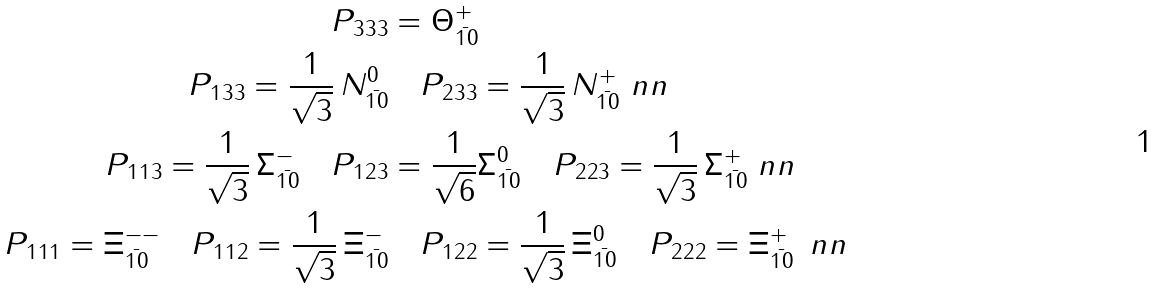<formula> <loc_0><loc_0><loc_500><loc_500>P _ { 3 3 3 } & = \Theta ^ { + } _ { \bar { 1 0 } } \\ P _ { 1 3 3 } = \frac { 1 } { \sqrt { 3 } } \, N ^ { 0 } _ { \bar { 1 0 } } & \quad P _ { 2 3 3 } = \frac { 1 } { \sqrt { 3 } } \, N ^ { + } _ { \bar { 1 0 } } \ n n \\ P _ { 1 1 3 } = \frac { 1 } { \sqrt { 3 } } \, \Sigma ^ { - } _ { \bar { 1 0 } } \quad P _ { 1 2 3 } & = \frac { 1 } { \sqrt { 6 } } \Sigma ^ { 0 } _ { \bar { 1 0 } } \quad P _ { 2 2 3 } = \frac { 1 } { \sqrt { 3 } } \, \Sigma ^ { + } _ { \bar { 1 0 } } \ n n \\ P _ { 1 1 1 } = \Xi ^ { - - } _ { \bar { 1 0 } } \quad P _ { 1 1 2 } = \frac { 1 } { \sqrt { 3 } } \, \Xi _ { \bar { 1 0 } } ^ { - } & \quad P _ { 1 2 2 } = \frac { 1 } { \sqrt { 3 } } \, \Xi _ { \bar { 1 0 } } ^ { 0 } \quad P _ { 2 2 2 } = \Xi _ { \bar { 1 0 } } ^ { + } \, \ n n</formula> 